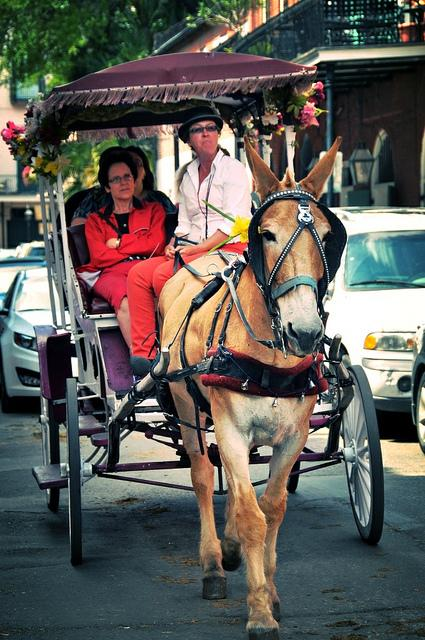What is this horse being used for? transportation 